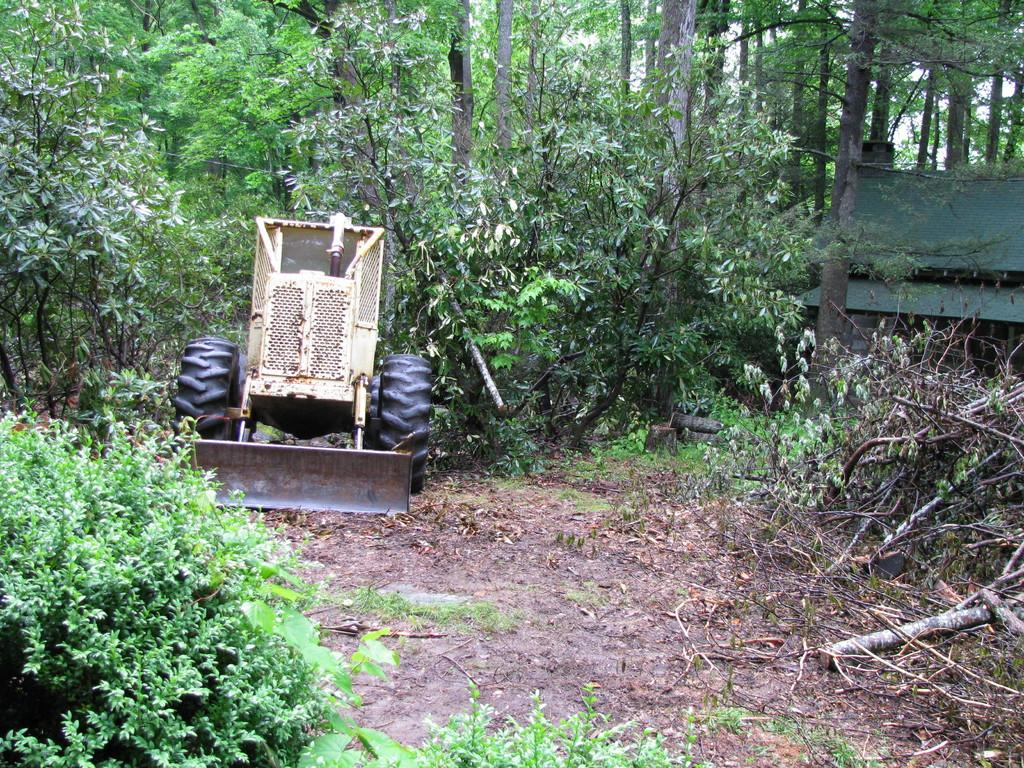What type of living organisms can be seen in the image? Plants and trees are visible in the image. Can you describe the vehicle in the image? There is a vehicle in the image, but its specific type is not mentioned. What is the natural setting visible in the image? The natural setting includes plants and trees. What type of finger can be seen pointing at the governor in the image? There is no governor or finger present in the image. 